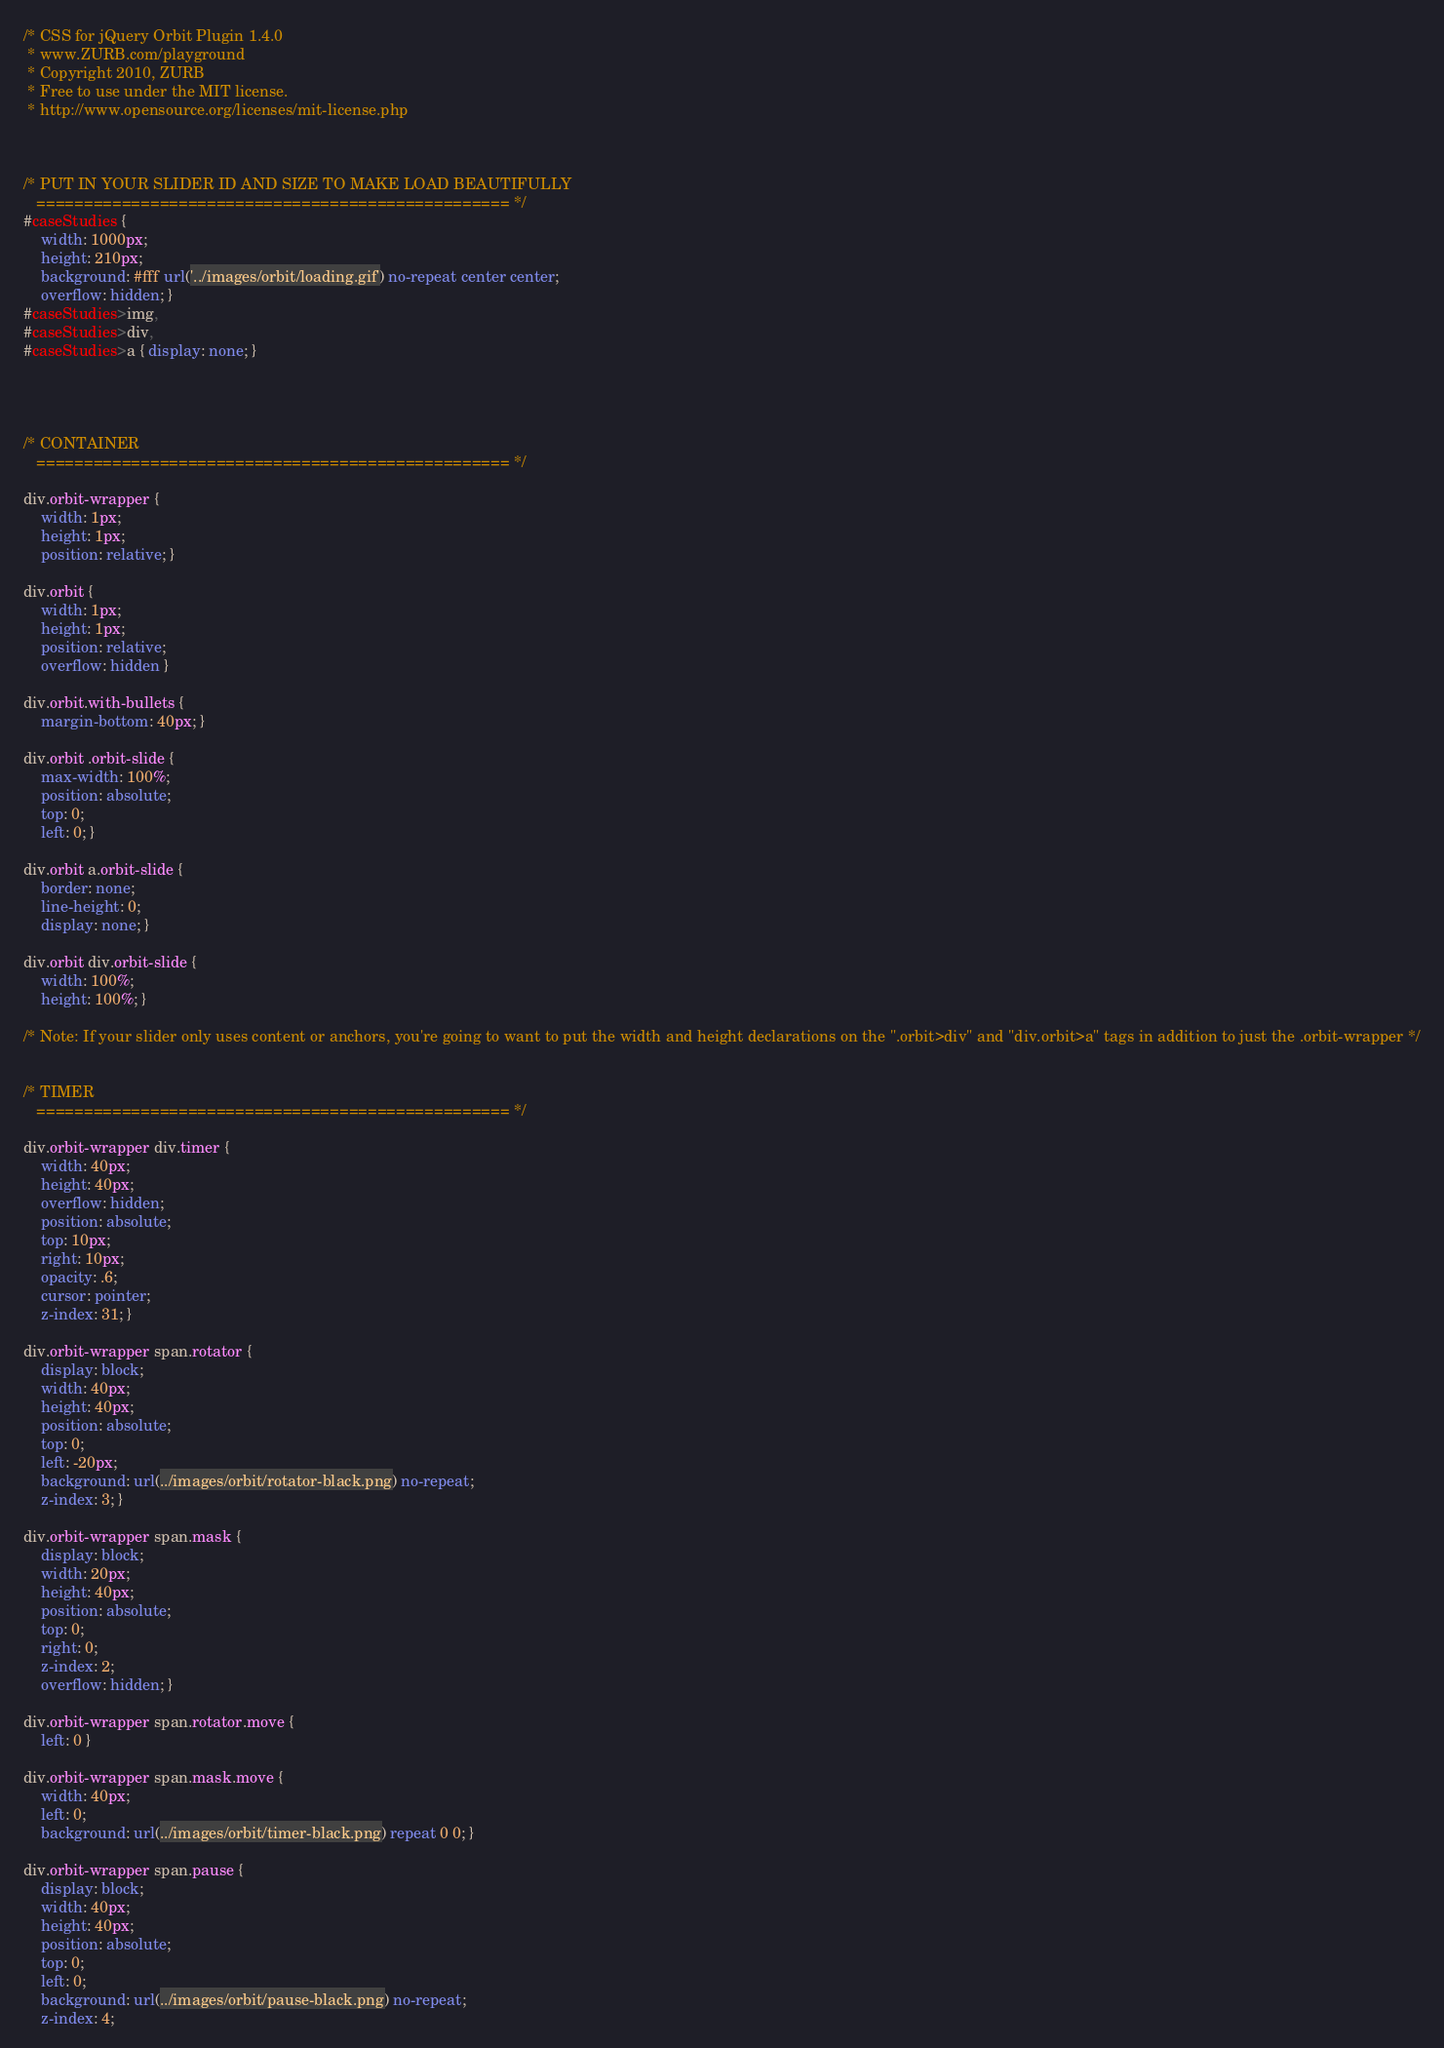<code> <loc_0><loc_0><loc_500><loc_500><_CSS_>/* CSS for jQuery Orbit Plugin 1.4.0
 * www.ZURB.com/playground
 * Copyright 2010, ZURB
 * Free to use under the MIT license.
 * http://www.opensource.org/licenses/mit-license.php
 
 
 
/* PUT IN YOUR SLIDER ID AND SIZE TO MAKE LOAD BEAUTIFULLY
   ================================================== */
#caseStudies { 
	width: 1000px;
	height: 210px;
	background: #fff url('../images/orbit/loading.gif') no-repeat center center;
	overflow: hidden; }
#caseStudies>img,  
#caseStudies>div,
#caseStudies>a { display: none; }




/* CONTAINER
   ================================================== */

div.orbit-wrapper {
    width: 1px;
    height: 1px;
    position: relative; }

div.orbit {
    width: 1px;
    height: 1px;
    position: relative;
    overflow: hidden }
    
div.orbit.with-bullets {
    margin-bottom: 40px; }

div.orbit .orbit-slide {
    max-width: 100%;
    position: absolute;
    top: 0;
    left: 0; }

div.orbit a.orbit-slide {
    border: none;
    line-height: 0; 
    display: none; }

div.orbit div.orbit-slide {
    width: 100%;
    height: 100%; }

/* Note: If your slider only uses content or anchors, you're going to want to put the width and height declarations on the ".orbit>div" and "div.orbit>a" tags in addition to just the .orbit-wrapper */


/* TIMER
   ================================================== */

div.orbit-wrapper div.timer {
    width: 40px;
    height: 40px;
    overflow: hidden;
    position: absolute;
    top: 10px;
    right: 10px;
    opacity: .6;
    cursor: pointer;
    z-index: 31; }

div.orbit-wrapper span.rotator {
    display: block;
    width: 40px;
    height: 40px;
    position: absolute;
    top: 0;
    left: -20px;
    background: url(../images/orbit/rotator-black.png) no-repeat;
    z-index: 3; }

div.orbit-wrapper span.mask {
    display: block;
    width: 20px;
    height: 40px;
    position: absolute;
    top: 0;
    right: 0;
    z-index: 2;
    overflow: hidden; }

div.orbit-wrapper span.rotator.move {
    left: 0 }

div.orbit-wrapper span.mask.move {
    width: 40px;
    left: 0;
    background: url(../images/orbit/timer-black.png) repeat 0 0; }

div.orbit-wrapper span.pause {
    display: block;
    width: 40px;
    height: 40px;
    position: absolute;
    top: 0;
    left: 0;
    background: url(../images/orbit/pause-black.png) no-repeat;
    z-index: 4;</code> 